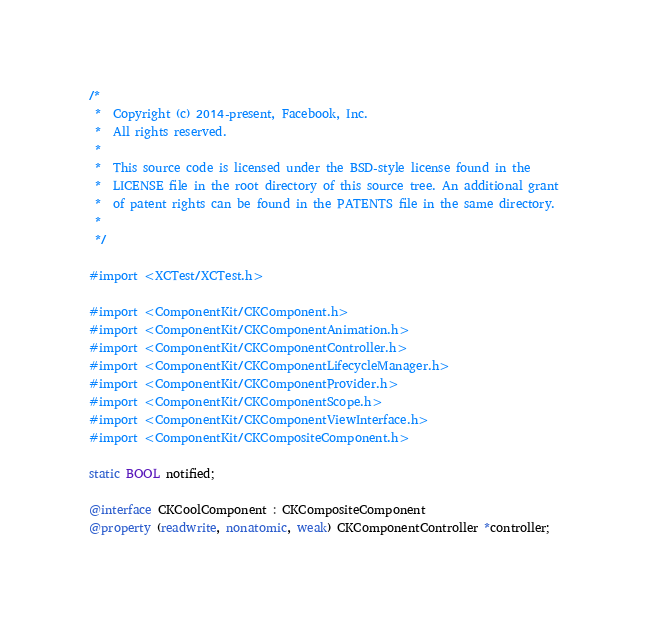Convert code to text. <code><loc_0><loc_0><loc_500><loc_500><_ObjectiveC_>/*
 *  Copyright (c) 2014-present, Facebook, Inc.
 *  All rights reserved.
 *
 *  This source code is licensed under the BSD-style license found in the
 *  LICENSE file in the root directory of this source tree. An additional grant
 *  of patent rights can be found in the PATENTS file in the same directory.
 *
 */

#import <XCTest/XCTest.h>

#import <ComponentKit/CKComponent.h>
#import <ComponentKit/CKComponentAnimation.h>
#import <ComponentKit/CKComponentController.h>
#import <ComponentKit/CKComponentLifecycleManager.h>
#import <ComponentKit/CKComponentProvider.h>
#import <ComponentKit/CKComponentScope.h>
#import <ComponentKit/CKComponentViewInterface.h>
#import <ComponentKit/CKCompositeComponent.h>

static BOOL notified;

@interface CKCoolComponent : CKCompositeComponent
@property (readwrite, nonatomic, weak) CKComponentController *controller;</code> 